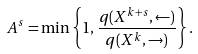Convert formula to latex. <formula><loc_0><loc_0><loc_500><loc_500>A ^ { s } = \min \left \{ 1 , \frac { q ( X ^ { k + s } , \leftarrow ) } { q ( X ^ { k } , \rightarrow ) } \right \} .</formula> 